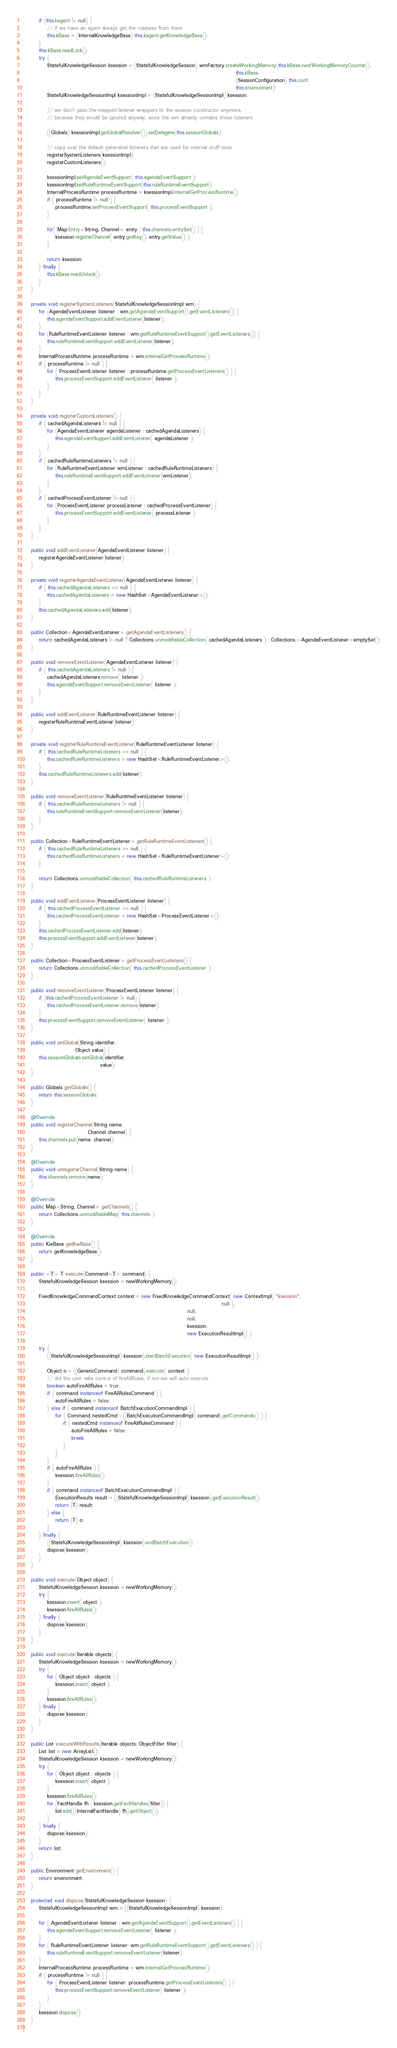<code> <loc_0><loc_0><loc_500><loc_500><_Java_>        if (this.kagent != null) {
            // if we have an agent always get the rulebase from there
            this.kBase = (InternalKnowledgeBase) this.kagent.getKnowledgeBase();
        }
        this.kBase.readLock();
        try {
            StatefulKnowledgeSession ksession = (StatefulKnowledgeSession) wmFactory.createWorkingMemory(this.kBase.nextWorkingMemoryCounter(),
                                                                                                         this.kBase,
                                                                                                         (SessionConfiguration) this.conf,
                                                                                                         this.environment);
            StatefulKnowledgeSessionImpl ksessionImpl = (StatefulKnowledgeSessionImpl) ksession;

            // we don't pass the mapped listener wrappers to the session constructor anymore,
            // because they would be ignored anyway, since the wm already contains those listeners

            ((Globals) ksessionImpl.getGlobalResolver()).setDelegate(this.sessionGlobals);

            // copy over the default generated listeners that are used for internal stuff once
            registerSystemListeners(ksessionImpl);
            registerCustomListeners();

            ksessionImpl.setAgendaEventSupport( this.agendaEventSupport );
            ksessionImpl.setRuleRuntimeEventSupport(this.ruleRuntimeEventSupport);
            InternalProcessRuntime processRuntime = ksessionImpl.internalGetProcessRuntime();
            if ( processRuntime != null ) {
                processRuntime.setProcessEventSupport( this.processEventSupport );
            }

            for( Map.Entry<String, Channel> entry : this.channels.entrySet() ) {
                ksession.registerChannel( entry.getKey(), entry.getValue() );
            }

            return ksession;
        } finally {
            this.kBase.readUnlock();
        }
    }

    private void registerSystemListeners(StatefulKnowledgeSessionImpl wm) {
        for (AgendaEventListener listener : wm.getAgendaEventSupport().getEventListeners()) {
            this.agendaEventSupport.addEventListener(listener);
        }
        for (RuleRuntimeEventListener listener : wm.getRuleRuntimeEventSupport().getEventListeners()) {
            this.ruleRuntimeEventSupport.addEventListener(listener);
        }
        InternalProcessRuntime processRuntime = wm.internalGetProcessRuntime();
        if ( processRuntime != null ) {
            for ( ProcessEventListener listener : processRuntime.getProcessEventListeners() ) {
                this.processEventSupport.addEventListener( listener );
            }
        }
    }

    private void registerCustomListeners() {
        if ( cachedAgendaListeners != null ) {
            for (AgendaEventListener agendaListener : cachedAgendaListeners) {
                this.agendaEventSupport.addEventListener( agendaListener );
            }
        }
        if ( cachedRuleRuntimeListeners != null ) {
            for (RuleRuntimeEventListener wmListener : cachedRuleRuntimeListeners) {
                this.ruleRuntimeEventSupport.addEventListener(wmListener);
            }
        }
        if ( cachedProcessEventListener != null ) {
            for (ProcessEventListener processListener : cachedProcessEventListener) {
                this.processEventSupport.addEventListener( processListener );
            }
        }
    }

    public void addEventListener(AgendaEventListener listener) {
        registerAgendaEventListener(listener);
    }

    private void registerAgendaEventListener(AgendaEventListener listener) {
        if ( this.cachedAgendaListeners == null ) {
            this.cachedAgendaListeners = new HashSet<AgendaEventListener>();
        }
        this.cachedAgendaListeners.add(listener);
    }

    public Collection<AgendaEventListener> getAgendaEventListeners() {
        return cachedAgendaListeners != null ? Collections.unmodifiableCollection( cachedAgendaListeners ) : Collections.<AgendaEventListener>emptySet();
    }

    public void removeEventListener(AgendaEventListener listener) {
        if ( this.cachedAgendaListeners != null ) {
            cachedAgendaListeners.remove( listener );
            this.agendaEventSupport.removeEventListener( listener );
        }
    }

    public void addEventListener(RuleRuntimeEventListener listener) {
        registerRuleRuntimeEventListener(listener);
    }

    private void registerRuleRuntimeEventListener(RuleRuntimeEventListener listener) {
        if ( this.cachedRuleRuntimeListeners == null ) {
            this.cachedRuleRuntimeListeners = new HashSet<RuleRuntimeEventListener>();
        }
        this.cachedRuleRuntimeListeners.add(listener);
    }

    public void removeEventListener(RuleRuntimeEventListener listener) {
        if ( this.cachedRuleRuntimeListeners != null ) {
            this.ruleRuntimeEventSupport.removeEventListener(listener);
        }
    }

    public Collection<RuleRuntimeEventListener> getRuleRuntimeEventListeners() {
        if ( this.cachedRuleRuntimeListeners == null ) {
            this.cachedRuleRuntimeListeners = new HashSet<RuleRuntimeEventListener>();
        }

        return Collections.unmodifiableCollection( this.cachedRuleRuntimeListeners );
    }

    public void addEventListener(ProcessEventListener listener) {
        if ( this.cachedProcessEventListener == null ) {
            this.cachedProcessEventListener = new HashSet<ProcessEventListener>();
        }
        this.cachedProcessEventListener.add(listener);
        this.processEventSupport.addEventListener(listener);
    }

    public Collection<ProcessEventListener> getProcessEventListeners() {
        return Collections.unmodifiableCollection( this.cachedProcessEventListener );
    }

    public void removeEventListener(ProcessEventListener listener) {
        if (this.cachedProcessEventListener != null) {
            this.cachedProcessEventListener.remove(listener);
        }
        this.processEventSupport.removeEventListener( listener );
    }

    public void setGlobal(String identifier,
                          Object value) {
        this.sessionGlobals.setGlobal(identifier,
                                      value);
    }

    public Globals getGlobals() {
        return this.sessionGlobals;
    }
    
    @Override
    public void registerChannel(String name,
                                Channel channel) {
        this.channels.put(name, channel);
    }
    
    @Override
    public void unregisterChannel(String name) {
        this.channels.remove(name);
    }
    
    @Override
    public Map<String, Channel> getChannels() {
        return Collections.unmodifiableMap( this.channels );
    }

    @Override
    public KieBase getKieBase() {
        return getKnowledgeBase();
    }

    public <T> T execute(Command<T> command) {
        StatefulKnowledgeSession ksession = newWorkingMemory();

        FixedKnowledgeCommandContext context = new FixedKnowledgeCommandContext( new ContextImpl( "ksession",
                                                                                                  null ),
                                                                                 null,
                                                                                 null,
                                                                                 ksession,
                                                                                 new ExecutionResultImpl() );

        try {
            ((StatefulKnowledgeSessionImpl) ksession).startBatchExecution( new ExecutionResultImpl() );

            Object o = ((GenericCommand) command).execute( context );
            // did the user take control of fireAllRules, if not we will auto execute
            boolean autoFireAllRules = true;
            if ( command instanceof FireAllRulesCommand ) {
                autoFireAllRules = false;
            } else if ( command instanceof BatchExecutionCommandImpl ) {
                for ( Command nestedCmd : ((BatchExecutionCommandImpl) command).getCommands() ) {
                    if ( nestedCmd instanceof FireAllRulesCommand ) {
                        autoFireAllRules = false;
                        break;
                    }
                }
            }
            if ( autoFireAllRules ) {
                ksession.fireAllRules();
            }
            if ( command instanceof BatchExecutionCommandImpl ) {
                ExecutionResults result = ((StatefulKnowledgeSessionImpl) ksession).getExecutionResult();
                return (T) result;
            } else {
                return (T) o;
            }
        } finally {
            ((StatefulKnowledgeSessionImpl) ksession).endBatchExecution();
            dispose(ksession);
        }
    }

    public void execute(Object object) {
        StatefulKnowledgeSession ksession = newWorkingMemory();
        try {
            ksession.insert( object );
            ksession.fireAllRules();
        } finally {
            dispose(ksession);
        }
    }

    public void execute(Iterable objects) {
        StatefulKnowledgeSession ksession = newWorkingMemory();
        try {
            for ( Object object : objects ) {
                ksession.insert( object );
            }
            ksession.fireAllRules();
        } finally {
            dispose(ksession);
        }
    }

    public List executeWithResults(Iterable objects, ObjectFilter filter) {
        List list = new ArrayList();
        StatefulKnowledgeSession ksession = newWorkingMemory();
        try {
            for ( Object object : objects ) {
                ksession.insert( object );
            }
            ksession.fireAllRules();
            for (FactHandle fh : ksession.getFactHandles(filter)) {
                list.add(((InternalFactHandle) fh).getObject());
            }
        } finally {
            dispose(ksession);
        }
        return list;
    }

    public Environment getEnvironment() {
        return environment;
    }

    protected void dispose(StatefulKnowledgeSession ksession) {
        StatefulKnowledgeSessionImpl wm = ((StatefulKnowledgeSessionImpl) ksession);

        for ( AgendaEventListener listener : wm.getAgendaEventSupport().getEventListeners() ) {
            this.agendaEventSupport.removeEventListener( listener );
        }
        for ( RuleRuntimeEventListener listener: wm.getRuleRuntimeEventSupport().getEventListeners() ) {
            this.ruleRuntimeEventSupport.removeEventListener(listener);
        }
        InternalProcessRuntime processRuntime = wm.internalGetProcessRuntime();
        if ( processRuntime != null ) {
            for ( ProcessEventListener listener: processRuntime.getProcessEventListeners() ) {
                this.processEventSupport.removeEventListener( listener );
            }
        }
        ksession.dispose();
    }
}
</code> 